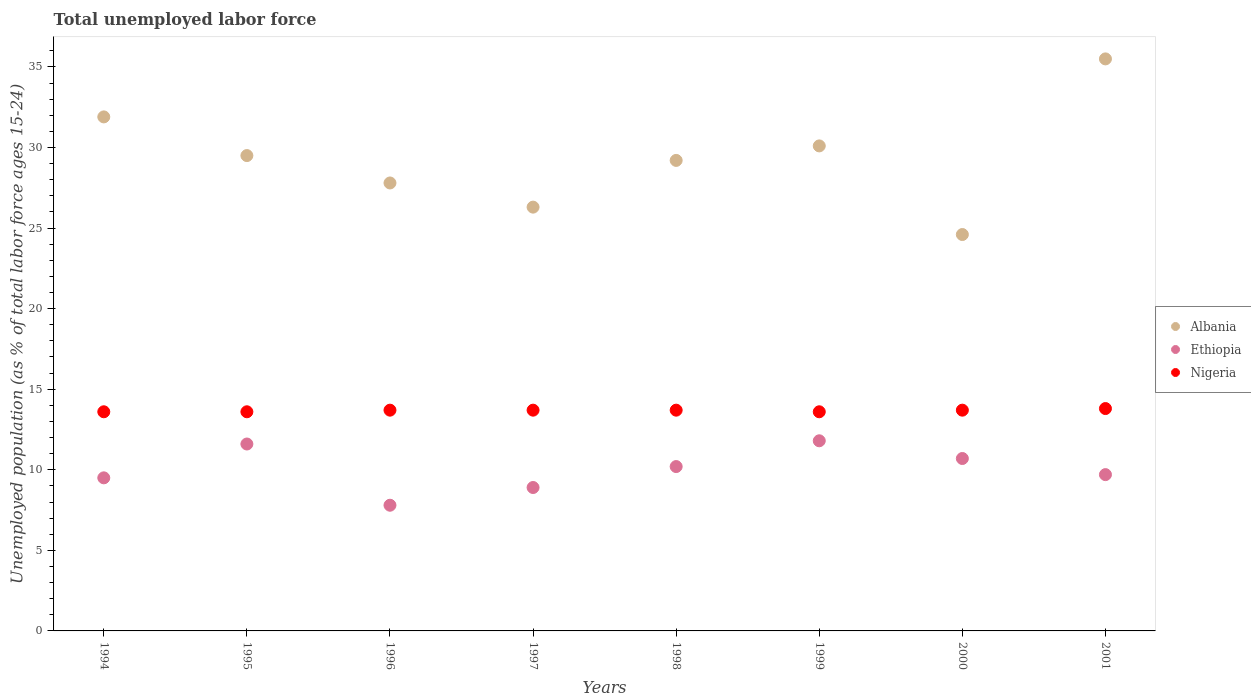Is the number of dotlines equal to the number of legend labels?
Provide a succinct answer. Yes. What is the percentage of unemployed population in in Albania in 1995?
Offer a very short reply. 29.5. Across all years, what is the maximum percentage of unemployed population in in Nigeria?
Provide a short and direct response. 13.8. Across all years, what is the minimum percentage of unemployed population in in Albania?
Your response must be concise. 24.6. In which year was the percentage of unemployed population in in Albania minimum?
Provide a succinct answer. 2000. What is the total percentage of unemployed population in in Ethiopia in the graph?
Your response must be concise. 80.2. What is the difference between the percentage of unemployed population in in Ethiopia in 1994 and that in 2000?
Make the answer very short. -1.2. What is the difference between the percentage of unemployed population in in Nigeria in 1997 and the percentage of unemployed population in in Albania in 1995?
Make the answer very short. -15.8. What is the average percentage of unemployed population in in Ethiopia per year?
Offer a very short reply. 10.02. In the year 1999, what is the difference between the percentage of unemployed population in in Nigeria and percentage of unemployed population in in Ethiopia?
Your response must be concise. 1.8. In how many years, is the percentage of unemployed population in in Nigeria greater than 16 %?
Give a very brief answer. 0. What is the ratio of the percentage of unemployed population in in Ethiopia in 1997 to that in 1999?
Offer a terse response. 0.75. What is the difference between the highest and the second highest percentage of unemployed population in in Nigeria?
Provide a short and direct response. 0.1. What is the difference between the highest and the lowest percentage of unemployed population in in Nigeria?
Offer a very short reply. 0.2. In how many years, is the percentage of unemployed population in in Nigeria greater than the average percentage of unemployed population in in Nigeria taken over all years?
Provide a short and direct response. 5. Is it the case that in every year, the sum of the percentage of unemployed population in in Ethiopia and percentage of unemployed population in in Albania  is greater than the percentage of unemployed population in in Nigeria?
Keep it short and to the point. Yes. Is the percentage of unemployed population in in Ethiopia strictly less than the percentage of unemployed population in in Nigeria over the years?
Give a very brief answer. Yes. What is the difference between two consecutive major ticks on the Y-axis?
Make the answer very short. 5. Does the graph contain grids?
Give a very brief answer. No. What is the title of the graph?
Keep it short and to the point. Total unemployed labor force. What is the label or title of the Y-axis?
Your response must be concise. Unemployed population (as % of total labor force ages 15-24). What is the Unemployed population (as % of total labor force ages 15-24) of Albania in 1994?
Offer a very short reply. 31.9. What is the Unemployed population (as % of total labor force ages 15-24) of Ethiopia in 1994?
Offer a terse response. 9.5. What is the Unemployed population (as % of total labor force ages 15-24) in Nigeria in 1994?
Provide a short and direct response. 13.6. What is the Unemployed population (as % of total labor force ages 15-24) of Albania in 1995?
Keep it short and to the point. 29.5. What is the Unemployed population (as % of total labor force ages 15-24) of Ethiopia in 1995?
Your answer should be very brief. 11.6. What is the Unemployed population (as % of total labor force ages 15-24) of Nigeria in 1995?
Give a very brief answer. 13.6. What is the Unemployed population (as % of total labor force ages 15-24) of Albania in 1996?
Offer a very short reply. 27.8. What is the Unemployed population (as % of total labor force ages 15-24) in Ethiopia in 1996?
Provide a short and direct response. 7.8. What is the Unemployed population (as % of total labor force ages 15-24) in Nigeria in 1996?
Your answer should be compact. 13.7. What is the Unemployed population (as % of total labor force ages 15-24) of Albania in 1997?
Ensure brevity in your answer.  26.3. What is the Unemployed population (as % of total labor force ages 15-24) of Ethiopia in 1997?
Make the answer very short. 8.9. What is the Unemployed population (as % of total labor force ages 15-24) in Nigeria in 1997?
Your answer should be compact. 13.7. What is the Unemployed population (as % of total labor force ages 15-24) in Albania in 1998?
Offer a very short reply. 29.2. What is the Unemployed population (as % of total labor force ages 15-24) of Ethiopia in 1998?
Offer a very short reply. 10.2. What is the Unemployed population (as % of total labor force ages 15-24) in Nigeria in 1998?
Provide a short and direct response. 13.7. What is the Unemployed population (as % of total labor force ages 15-24) of Albania in 1999?
Ensure brevity in your answer.  30.1. What is the Unemployed population (as % of total labor force ages 15-24) of Ethiopia in 1999?
Keep it short and to the point. 11.8. What is the Unemployed population (as % of total labor force ages 15-24) in Nigeria in 1999?
Provide a succinct answer. 13.6. What is the Unemployed population (as % of total labor force ages 15-24) of Albania in 2000?
Your answer should be compact. 24.6. What is the Unemployed population (as % of total labor force ages 15-24) of Ethiopia in 2000?
Make the answer very short. 10.7. What is the Unemployed population (as % of total labor force ages 15-24) in Nigeria in 2000?
Ensure brevity in your answer.  13.7. What is the Unemployed population (as % of total labor force ages 15-24) in Albania in 2001?
Keep it short and to the point. 35.5. What is the Unemployed population (as % of total labor force ages 15-24) in Ethiopia in 2001?
Your answer should be very brief. 9.7. What is the Unemployed population (as % of total labor force ages 15-24) in Nigeria in 2001?
Offer a very short reply. 13.8. Across all years, what is the maximum Unemployed population (as % of total labor force ages 15-24) in Albania?
Make the answer very short. 35.5. Across all years, what is the maximum Unemployed population (as % of total labor force ages 15-24) in Ethiopia?
Provide a succinct answer. 11.8. Across all years, what is the maximum Unemployed population (as % of total labor force ages 15-24) in Nigeria?
Ensure brevity in your answer.  13.8. Across all years, what is the minimum Unemployed population (as % of total labor force ages 15-24) in Albania?
Make the answer very short. 24.6. Across all years, what is the minimum Unemployed population (as % of total labor force ages 15-24) in Ethiopia?
Provide a succinct answer. 7.8. Across all years, what is the minimum Unemployed population (as % of total labor force ages 15-24) of Nigeria?
Your response must be concise. 13.6. What is the total Unemployed population (as % of total labor force ages 15-24) of Albania in the graph?
Your answer should be compact. 234.9. What is the total Unemployed population (as % of total labor force ages 15-24) of Ethiopia in the graph?
Your response must be concise. 80.2. What is the total Unemployed population (as % of total labor force ages 15-24) of Nigeria in the graph?
Provide a succinct answer. 109.4. What is the difference between the Unemployed population (as % of total labor force ages 15-24) of Albania in 1994 and that in 1995?
Your response must be concise. 2.4. What is the difference between the Unemployed population (as % of total labor force ages 15-24) in Ethiopia in 1994 and that in 1995?
Your response must be concise. -2.1. What is the difference between the Unemployed population (as % of total labor force ages 15-24) of Ethiopia in 1994 and that in 1996?
Offer a very short reply. 1.7. What is the difference between the Unemployed population (as % of total labor force ages 15-24) of Nigeria in 1994 and that in 1996?
Keep it short and to the point. -0.1. What is the difference between the Unemployed population (as % of total labor force ages 15-24) of Ethiopia in 1994 and that in 1997?
Offer a terse response. 0.6. What is the difference between the Unemployed population (as % of total labor force ages 15-24) in Albania in 1994 and that in 1998?
Provide a short and direct response. 2.7. What is the difference between the Unemployed population (as % of total labor force ages 15-24) of Ethiopia in 1994 and that in 1998?
Offer a terse response. -0.7. What is the difference between the Unemployed population (as % of total labor force ages 15-24) of Nigeria in 1994 and that in 1998?
Provide a short and direct response. -0.1. What is the difference between the Unemployed population (as % of total labor force ages 15-24) of Albania in 1994 and that in 1999?
Your answer should be compact. 1.8. What is the difference between the Unemployed population (as % of total labor force ages 15-24) in Ethiopia in 1994 and that in 1999?
Keep it short and to the point. -2.3. What is the difference between the Unemployed population (as % of total labor force ages 15-24) of Nigeria in 1994 and that in 2000?
Your response must be concise. -0.1. What is the difference between the Unemployed population (as % of total labor force ages 15-24) in Albania in 1994 and that in 2001?
Your answer should be very brief. -3.6. What is the difference between the Unemployed population (as % of total labor force ages 15-24) of Nigeria in 1994 and that in 2001?
Provide a short and direct response. -0.2. What is the difference between the Unemployed population (as % of total labor force ages 15-24) of Ethiopia in 1995 and that in 1996?
Your answer should be very brief. 3.8. What is the difference between the Unemployed population (as % of total labor force ages 15-24) of Nigeria in 1995 and that in 1996?
Offer a very short reply. -0.1. What is the difference between the Unemployed population (as % of total labor force ages 15-24) in Albania in 1995 and that in 1998?
Offer a very short reply. 0.3. What is the difference between the Unemployed population (as % of total labor force ages 15-24) of Nigeria in 1995 and that in 1998?
Make the answer very short. -0.1. What is the difference between the Unemployed population (as % of total labor force ages 15-24) of Nigeria in 1995 and that in 1999?
Make the answer very short. 0. What is the difference between the Unemployed population (as % of total labor force ages 15-24) of Albania in 1995 and that in 2000?
Provide a succinct answer. 4.9. What is the difference between the Unemployed population (as % of total labor force ages 15-24) of Ethiopia in 1995 and that in 2000?
Your answer should be very brief. 0.9. What is the difference between the Unemployed population (as % of total labor force ages 15-24) of Ethiopia in 1995 and that in 2001?
Make the answer very short. 1.9. What is the difference between the Unemployed population (as % of total labor force ages 15-24) of Nigeria in 1996 and that in 1997?
Your answer should be compact. 0. What is the difference between the Unemployed population (as % of total labor force ages 15-24) in Albania in 1996 and that in 1998?
Provide a short and direct response. -1.4. What is the difference between the Unemployed population (as % of total labor force ages 15-24) in Nigeria in 1996 and that in 1998?
Keep it short and to the point. 0. What is the difference between the Unemployed population (as % of total labor force ages 15-24) of Albania in 1996 and that in 2000?
Provide a succinct answer. 3.2. What is the difference between the Unemployed population (as % of total labor force ages 15-24) of Ethiopia in 1996 and that in 2000?
Make the answer very short. -2.9. What is the difference between the Unemployed population (as % of total labor force ages 15-24) in Nigeria in 1996 and that in 2000?
Make the answer very short. 0. What is the difference between the Unemployed population (as % of total labor force ages 15-24) of Ethiopia in 1996 and that in 2001?
Your response must be concise. -1.9. What is the difference between the Unemployed population (as % of total labor force ages 15-24) of Albania in 1997 and that in 1998?
Offer a very short reply. -2.9. What is the difference between the Unemployed population (as % of total labor force ages 15-24) of Nigeria in 1997 and that in 1998?
Keep it short and to the point. 0. What is the difference between the Unemployed population (as % of total labor force ages 15-24) of Nigeria in 1997 and that in 1999?
Give a very brief answer. 0.1. What is the difference between the Unemployed population (as % of total labor force ages 15-24) of Ethiopia in 1997 and that in 2000?
Make the answer very short. -1.8. What is the difference between the Unemployed population (as % of total labor force ages 15-24) in Albania in 1997 and that in 2001?
Your response must be concise. -9.2. What is the difference between the Unemployed population (as % of total labor force ages 15-24) of Ethiopia in 1997 and that in 2001?
Give a very brief answer. -0.8. What is the difference between the Unemployed population (as % of total labor force ages 15-24) of Nigeria in 1997 and that in 2001?
Provide a short and direct response. -0.1. What is the difference between the Unemployed population (as % of total labor force ages 15-24) of Albania in 1998 and that in 1999?
Provide a short and direct response. -0.9. What is the difference between the Unemployed population (as % of total labor force ages 15-24) of Nigeria in 1998 and that in 1999?
Your answer should be very brief. 0.1. What is the difference between the Unemployed population (as % of total labor force ages 15-24) of Ethiopia in 1998 and that in 2000?
Offer a very short reply. -0.5. What is the difference between the Unemployed population (as % of total labor force ages 15-24) in Albania in 1998 and that in 2001?
Provide a succinct answer. -6.3. What is the difference between the Unemployed population (as % of total labor force ages 15-24) of Nigeria in 1998 and that in 2001?
Ensure brevity in your answer.  -0.1. What is the difference between the Unemployed population (as % of total labor force ages 15-24) in Albania in 1999 and that in 2000?
Your response must be concise. 5.5. What is the difference between the Unemployed population (as % of total labor force ages 15-24) of Albania in 1999 and that in 2001?
Provide a short and direct response. -5.4. What is the difference between the Unemployed population (as % of total labor force ages 15-24) in Ethiopia in 1999 and that in 2001?
Offer a terse response. 2.1. What is the difference between the Unemployed population (as % of total labor force ages 15-24) in Ethiopia in 2000 and that in 2001?
Your answer should be compact. 1. What is the difference between the Unemployed population (as % of total labor force ages 15-24) of Nigeria in 2000 and that in 2001?
Your answer should be compact. -0.1. What is the difference between the Unemployed population (as % of total labor force ages 15-24) in Albania in 1994 and the Unemployed population (as % of total labor force ages 15-24) in Ethiopia in 1995?
Your answer should be compact. 20.3. What is the difference between the Unemployed population (as % of total labor force ages 15-24) in Ethiopia in 1994 and the Unemployed population (as % of total labor force ages 15-24) in Nigeria in 1995?
Your answer should be very brief. -4.1. What is the difference between the Unemployed population (as % of total labor force ages 15-24) of Albania in 1994 and the Unemployed population (as % of total labor force ages 15-24) of Ethiopia in 1996?
Your response must be concise. 24.1. What is the difference between the Unemployed population (as % of total labor force ages 15-24) of Albania in 1994 and the Unemployed population (as % of total labor force ages 15-24) of Nigeria in 1996?
Offer a terse response. 18.2. What is the difference between the Unemployed population (as % of total labor force ages 15-24) in Ethiopia in 1994 and the Unemployed population (as % of total labor force ages 15-24) in Nigeria in 1996?
Give a very brief answer. -4.2. What is the difference between the Unemployed population (as % of total labor force ages 15-24) of Albania in 1994 and the Unemployed population (as % of total labor force ages 15-24) of Nigeria in 1997?
Give a very brief answer. 18.2. What is the difference between the Unemployed population (as % of total labor force ages 15-24) in Albania in 1994 and the Unemployed population (as % of total labor force ages 15-24) in Ethiopia in 1998?
Your response must be concise. 21.7. What is the difference between the Unemployed population (as % of total labor force ages 15-24) of Ethiopia in 1994 and the Unemployed population (as % of total labor force ages 15-24) of Nigeria in 1998?
Your answer should be very brief. -4.2. What is the difference between the Unemployed population (as % of total labor force ages 15-24) in Albania in 1994 and the Unemployed population (as % of total labor force ages 15-24) in Ethiopia in 1999?
Give a very brief answer. 20.1. What is the difference between the Unemployed population (as % of total labor force ages 15-24) of Ethiopia in 1994 and the Unemployed population (as % of total labor force ages 15-24) of Nigeria in 1999?
Offer a very short reply. -4.1. What is the difference between the Unemployed population (as % of total labor force ages 15-24) of Albania in 1994 and the Unemployed population (as % of total labor force ages 15-24) of Ethiopia in 2000?
Your answer should be very brief. 21.2. What is the difference between the Unemployed population (as % of total labor force ages 15-24) in Albania in 1995 and the Unemployed population (as % of total labor force ages 15-24) in Ethiopia in 1996?
Your answer should be very brief. 21.7. What is the difference between the Unemployed population (as % of total labor force ages 15-24) in Albania in 1995 and the Unemployed population (as % of total labor force ages 15-24) in Ethiopia in 1997?
Your response must be concise. 20.6. What is the difference between the Unemployed population (as % of total labor force ages 15-24) of Albania in 1995 and the Unemployed population (as % of total labor force ages 15-24) of Nigeria in 1997?
Your answer should be very brief. 15.8. What is the difference between the Unemployed population (as % of total labor force ages 15-24) in Albania in 1995 and the Unemployed population (as % of total labor force ages 15-24) in Ethiopia in 1998?
Provide a succinct answer. 19.3. What is the difference between the Unemployed population (as % of total labor force ages 15-24) of Albania in 1995 and the Unemployed population (as % of total labor force ages 15-24) of Nigeria in 1998?
Give a very brief answer. 15.8. What is the difference between the Unemployed population (as % of total labor force ages 15-24) in Ethiopia in 1995 and the Unemployed population (as % of total labor force ages 15-24) in Nigeria in 1998?
Your answer should be very brief. -2.1. What is the difference between the Unemployed population (as % of total labor force ages 15-24) of Albania in 1995 and the Unemployed population (as % of total labor force ages 15-24) of Ethiopia in 1999?
Your answer should be compact. 17.7. What is the difference between the Unemployed population (as % of total labor force ages 15-24) in Albania in 1995 and the Unemployed population (as % of total labor force ages 15-24) in Nigeria in 1999?
Offer a terse response. 15.9. What is the difference between the Unemployed population (as % of total labor force ages 15-24) in Ethiopia in 1995 and the Unemployed population (as % of total labor force ages 15-24) in Nigeria in 1999?
Give a very brief answer. -2. What is the difference between the Unemployed population (as % of total labor force ages 15-24) of Albania in 1995 and the Unemployed population (as % of total labor force ages 15-24) of Ethiopia in 2000?
Offer a terse response. 18.8. What is the difference between the Unemployed population (as % of total labor force ages 15-24) in Albania in 1995 and the Unemployed population (as % of total labor force ages 15-24) in Nigeria in 2000?
Offer a terse response. 15.8. What is the difference between the Unemployed population (as % of total labor force ages 15-24) of Albania in 1995 and the Unemployed population (as % of total labor force ages 15-24) of Ethiopia in 2001?
Your answer should be compact. 19.8. What is the difference between the Unemployed population (as % of total labor force ages 15-24) of Ethiopia in 1996 and the Unemployed population (as % of total labor force ages 15-24) of Nigeria in 1997?
Offer a terse response. -5.9. What is the difference between the Unemployed population (as % of total labor force ages 15-24) in Albania in 1996 and the Unemployed population (as % of total labor force ages 15-24) in Ethiopia in 1998?
Your response must be concise. 17.6. What is the difference between the Unemployed population (as % of total labor force ages 15-24) in Albania in 1996 and the Unemployed population (as % of total labor force ages 15-24) in Ethiopia in 1999?
Provide a short and direct response. 16. What is the difference between the Unemployed population (as % of total labor force ages 15-24) of Ethiopia in 1996 and the Unemployed population (as % of total labor force ages 15-24) of Nigeria in 1999?
Make the answer very short. -5.8. What is the difference between the Unemployed population (as % of total labor force ages 15-24) of Albania in 1996 and the Unemployed population (as % of total labor force ages 15-24) of Ethiopia in 2000?
Your answer should be very brief. 17.1. What is the difference between the Unemployed population (as % of total labor force ages 15-24) of Albania in 1996 and the Unemployed population (as % of total labor force ages 15-24) of Nigeria in 2000?
Your answer should be compact. 14.1. What is the difference between the Unemployed population (as % of total labor force ages 15-24) in Ethiopia in 1996 and the Unemployed population (as % of total labor force ages 15-24) in Nigeria in 2000?
Your answer should be very brief. -5.9. What is the difference between the Unemployed population (as % of total labor force ages 15-24) in Albania in 1996 and the Unemployed population (as % of total labor force ages 15-24) in Ethiopia in 2001?
Keep it short and to the point. 18.1. What is the difference between the Unemployed population (as % of total labor force ages 15-24) in Albania in 1996 and the Unemployed population (as % of total labor force ages 15-24) in Nigeria in 2001?
Make the answer very short. 14. What is the difference between the Unemployed population (as % of total labor force ages 15-24) of Ethiopia in 1996 and the Unemployed population (as % of total labor force ages 15-24) of Nigeria in 2001?
Give a very brief answer. -6. What is the difference between the Unemployed population (as % of total labor force ages 15-24) in Albania in 1997 and the Unemployed population (as % of total labor force ages 15-24) in Ethiopia in 1998?
Ensure brevity in your answer.  16.1. What is the difference between the Unemployed population (as % of total labor force ages 15-24) in Ethiopia in 1997 and the Unemployed population (as % of total labor force ages 15-24) in Nigeria in 1998?
Give a very brief answer. -4.8. What is the difference between the Unemployed population (as % of total labor force ages 15-24) of Albania in 1997 and the Unemployed population (as % of total labor force ages 15-24) of Ethiopia in 2000?
Keep it short and to the point. 15.6. What is the difference between the Unemployed population (as % of total labor force ages 15-24) in Albania in 1997 and the Unemployed population (as % of total labor force ages 15-24) in Ethiopia in 2001?
Your response must be concise. 16.6. What is the difference between the Unemployed population (as % of total labor force ages 15-24) of Albania in 1997 and the Unemployed population (as % of total labor force ages 15-24) of Nigeria in 2001?
Your response must be concise. 12.5. What is the difference between the Unemployed population (as % of total labor force ages 15-24) in Ethiopia in 1997 and the Unemployed population (as % of total labor force ages 15-24) in Nigeria in 2001?
Your answer should be compact. -4.9. What is the difference between the Unemployed population (as % of total labor force ages 15-24) of Albania in 1998 and the Unemployed population (as % of total labor force ages 15-24) of Ethiopia in 1999?
Provide a succinct answer. 17.4. What is the difference between the Unemployed population (as % of total labor force ages 15-24) of Ethiopia in 1998 and the Unemployed population (as % of total labor force ages 15-24) of Nigeria in 2000?
Your answer should be very brief. -3.5. What is the difference between the Unemployed population (as % of total labor force ages 15-24) of Albania in 1998 and the Unemployed population (as % of total labor force ages 15-24) of Ethiopia in 2001?
Keep it short and to the point. 19.5. What is the difference between the Unemployed population (as % of total labor force ages 15-24) in Albania in 1998 and the Unemployed population (as % of total labor force ages 15-24) in Nigeria in 2001?
Make the answer very short. 15.4. What is the difference between the Unemployed population (as % of total labor force ages 15-24) of Albania in 1999 and the Unemployed population (as % of total labor force ages 15-24) of Ethiopia in 2000?
Provide a succinct answer. 19.4. What is the difference between the Unemployed population (as % of total labor force ages 15-24) of Albania in 1999 and the Unemployed population (as % of total labor force ages 15-24) of Nigeria in 2000?
Offer a terse response. 16.4. What is the difference between the Unemployed population (as % of total labor force ages 15-24) of Albania in 1999 and the Unemployed population (as % of total labor force ages 15-24) of Ethiopia in 2001?
Offer a terse response. 20.4. What is the difference between the Unemployed population (as % of total labor force ages 15-24) of Albania in 1999 and the Unemployed population (as % of total labor force ages 15-24) of Nigeria in 2001?
Provide a succinct answer. 16.3. What is the average Unemployed population (as % of total labor force ages 15-24) in Albania per year?
Give a very brief answer. 29.36. What is the average Unemployed population (as % of total labor force ages 15-24) in Ethiopia per year?
Offer a very short reply. 10.03. What is the average Unemployed population (as % of total labor force ages 15-24) of Nigeria per year?
Provide a short and direct response. 13.68. In the year 1994, what is the difference between the Unemployed population (as % of total labor force ages 15-24) in Albania and Unemployed population (as % of total labor force ages 15-24) in Ethiopia?
Make the answer very short. 22.4. In the year 1994, what is the difference between the Unemployed population (as % of total labor force ages 15-24) in Albania and Unemployed population (as % of total labor force ages 15-24) in Nigeria?
Give a very brief answer. 18.3. In the year 1995, what is the difference between the Unemployed population (as % of total labor force ages 15-24) of Ethiopia and Unemployed population (as % of total labor force ages 15-24) of Nigeria?
Provide a succinct answer. -2. In the year 1996, what is the difference between the Unemployed population (as % of total labor force ages 15-24) in Albania and Unemployed population (as % of total labor force ages 15-24) in Nigeria?
Your answer should be compact. 14.1. In the year 1996, what is the difference between the Unemployed population (as % of total labor force ages 15-24) in Ethiopia and Unemployed population (as % of total labor force ages 15-24) in Nigeria?
Your answer should be very brief. -5.9. In the year 1997, what is the difference between the Unemployed population (as % of total labor force ages 15-24) of Albania and Unemployed population (as % of total labor force ages 15-24) of Ethiopia?
Offer a terse response. 17.4. In the year 1998, what is the difference between the Unemployed population (as % of total labor force ages 15-24) of Albania and Unemployed population (as % of total labor force ages 15-24) of Ethiopia?
Make the answer very short. 19. In the year 1999, what is the difference between the Unemployed population (as % of total labor force ages 15-24) in Albania and Unemployed population (as % of total labor force ages 15-24) in Ethiopia?
Provide a short and direct response. 18.3. In the year 1999, what is the difference between the Unemployed population (as % of total labor force ages 15-24) in Albania and Unemployed population (as % of total labor force ages 15-24) in Nigeria?
Keep it short and to the point. 16.5. In the year 1999, what is the difference between the Unemployed population (as % of total labor force ages 15-24) of Ethiopia and Unemployed population (as % of total labor force ages 15-24) of Nigeria?
Provide a succinct answer. -1.8. In the year 2000, what is the difference between the Unemployed population (as % of total labor force ages 15-24) of Albania and Unemployed population (as % of total labor force ages 15-24) of Nigeria?
Ensure brevity in your answer.  10.9. In the year 2001, what is the difference between the Unemployed population (as % of total labor force ages 15-24) in Albania and Unemployed population (as % of total labor force ages 15-24) in Ethiopia?
Make the answer very short. 25.8. In the year 2001, what is the difference between the Unemployed population (as % of total labor force ages 15-24) of Albania and Unemployed population (as % of total labor force ages 15-24) of Nigeria?
Offer a terse response. 21.7. What is the ratio of the Unemployed population (as % of total labor force ages 15-24) in Albania in 1994 to that in 1995?
Your answer should be compact. 1.08. What is the ratio of the Unemployed population (as % of total labor force ages 15-24) in Ethiopia in 1994 to that in 1995?
Provide a succinct answer. 0.82. What is the ratio of the Unemployed population (as % of total labor force ages 15-24) in Nigeria in 1994 to that in 1995?
Ensure brevity in your answer.  1. What is the ratio of the Unemployed population (as % of total labor force ages 15-24) of Albania in 1994 to that in 1996?
Your response must be concise. 1.15. What is the ratio of the Unemployed population (as % of total labor force ages 15-24) of Ethiopia in 1994 to that in 1996?
Provide a succinct answer. 1.22. What is the ratio of the Unemployed population (as % of total labor force ages 15-24) of Albania in 1994 to that in 1997?
Keep it short and to the point. 1.21. What is the ratio of the Unemployed population (as % of total labor force ages 15-24) in Ethiopia in 1994 to that in 1997?
Make the answer very short. 1.07. What is the ratio of the Unemployed population (as % of total labor force ages 15-24) in Nigeria in 1994 to that in 1997?
Make the answer very short. 0.99. What is the ratio of the Unemployed population (as % of total labor force ages 15-24) of Albania in 1994 to that in 1998?
Give a very brief answer. 1.09. What is the ratio of the Unemployed population (as % of total labor force ages 15-24) in Ethiopia in 1994 to that in 1998?
Keep it short and to the point. 0.93. What is the ratio of the Unemployed population (as % of total labor force ages 15-24) of Nigeria in 1994 to that in 1998?
Your answer should be compact. 0.99. What is the ratio of the Unemployed population (as % of total labor force ages 15-24) of Albania in 1994 to that in 1999?
Ensure brevity in your answer.  1.06. What is the ratio of the Unemployed population (as % of total labor force ages 15-24) in Ethiopia in 1994 to that in 1999?
Give a very brief answer. 0.81. What is the ratio of the Unemployed population (as % of total labor force ages 15-24) in Albania in 1994 to that in 2000?
Keep it short and to the point. 1.3. What is the ratio of the Unemployed population (as % of total labor force ages 15-24) in Ethiopia in 1994 to that in 2000?
Keep it short and to the point. 0.89. What is the ratio of the Unemployed population (as % of total labor force ages 15-24) in Albania in 1994 to that in 2001?
Offer a very short reply. 0.9. What is the ratio of the Unemployed population (as % of total labor force ages 15-24) in Ethiopia in 1994 to that in 2001?
Your response must be concise. 0.98. What is the ratio of the Unemployed population (as % of total labor force ages 15-24) of Nigeria in 1994 to that in 2001?
Provide a succinct answer. 0.99. What is the ratio of the Unemployed population (as % of total labor force ages 15-24) of Albania in 1995 to that in 1996?
Your answer should be very brief. 1.06. What is the ratio of the Unemployed population (as % of total labor force ages 15-24) of Ethiopia in 1995 to that in 1996?
Offer a very short reply. 1.49. What is the ratio of the Unemployed population (as % of total labor force ages 15-24) of Nigeria in 1995 to that in 1996?
Your answer should be compact. 0.99. What is the ratio of the Unemployed population (as % of total labor force ages 15-24) of Albania in 1995 to that in 1997?
Make the answer very short. 1.12. What is the ratio of the Unemployed population (as % of total labor force ages 15-24) of Ethiopia in 1995 to that in 1997?
Ensure brevity in your answer.  1.3. What is the ratio of the Unemployed population (as % of total labor force ages 15-24) in Albania in 1995 to that in 1998?
Make the answer very short. 1.01. What is the ratio of the Unemployed population (as % of total labor force ages 15-24) of Ethiopia in 1995 to that in 1998?
Your answer should be compact. 1.14. What is the ratio of the Unemployed population (as % of total labor force ages 15-24) of Nigeria in 1995 to that in 1998?
Ensure brevity in your answer.  0.99. What is the ratio of the Unemployed population (as % of total labor force ages 15-24) in Albania in 1995 to that in 1999?
Provide a succinct answer. 0.98. What is the ratio of the Unemployed population (as % of total labor force ages 15-24) in Ethiopia in 1995 to that in 1999?
Your answer should be very brief. 0.98. What is the ratio of the Unemployed population (as % of total labor force ages 15-24) in Albania in 1995 to that in 2000?
Make the answer very short. 1.2. What is the ratio of the Unemployed population (as % of total labor force ages 15-24) in Ethiopia in 1995 to that in 2000?
Your response must be concise. 1.08. What is the ratio of the Unemployed population (as % of total labor force ages 15-24) in Nigeria in 1995 to that in 2000?
Provide a short and direct response. 0.99. What is the ratio of the Unemployed population (as % of total labor force ages 15-24) in Albania in 1995 to that in 2001?
Keep it short and to the point. 0.83. What is the ratio of the Unemployed population (as % of total labor force ages 15-24) in Ethiopia in 1995 to that in 2001?
Provide a short and direct response. 1.2. What is the ratio of the Unemployed population (as % of total labor force ages 15-24) in Nigeria in 1995 to that in 2001?
Provide a succinct answer. 0.99. What is the ratio of the Unemployed population (as % of total labor force ages 15-24) in Albania in 1996 to that in 1997?
Keep it short and to the point. 1.06. What is the ratio of the Unemployed population (as % of total labor force ages 15-24) of Ethiopia in 1996 to that in 1997?
Offer a terse response. 0.88. What is the ratio of the Unemployed population (as % of total labor force ages 15-24) in Albania in 1996 to that in 1998?
Your answer should be compact. 0.95. What is the ratio of the Unemployed population (as % of total labor force ages 15-24) of Ethiopia in 1996 to that in 1998?
Ensure brevity in your answer.  0.76. What is the ratio of the Unemployed population (as % of total labor force ages 15-24) in Albania in 1996 to that in 1999?
Ensure brevity in your answer.  0.92. What is the ratio of the Unemployed population (as % of total labor force ages 15-24) in Ethiopia in 1996 to that in 1999?
Provide a succinct answer. 0.66. What is the ratio of the Unemployed population (as % of total labor force ages 15-24) in Nigeria in 1996 to that in 1999?
Offer a terse response. 1.01. What is the ratio of the Unemployed population (as % of total labor force ages 15-24) in Albania in 1996 to that in 2000?
Offer a terse response. 1.13. What is the ratio of the Unemployed population (as % of total labor force ages 15-24) in Ethiopia in 1996 to that in 2000?
Offer a terse response. 0.73. What is the ratio of the Unemployed population (as % of total labor force ages 15-24) in Nigeria in 1996 to that in 2000?
Ensure brevity in your answer.  1. What is the ratio of the Unemployed population (as % of total labor force ages 15-24) of Albania in 1996 to that in 2001?
Offer a very short reply. 0.78. What is the ratio of the Unemployed population (as % of total labor force ages 15-24) of Ethiopia in 1996 to that in 2001?
Your answer should be very brief. 0.8. What is the ratio of the Unemployed population (as % of total labor force ages 15-24) in Nigeria in 1996 to that in 2001?
Provide a short and direct response. 0.99. What is the ratio of the Unemployed population (as % of total labor force ages 15-24) of Albania in 1997 to that in 1998?
Your answer should be very brief. 0.9. What is the ratio of the Unemployed population (as % of total labor force ages 15-24) in Ethiopia in 1997 to that in 1998?
Provide a short and direct response. 0.87. What is the ratio of the Unemployed population (as % of total labor force ages 15-24) of Albania in 1997 to that in 1999?
Give a very brief answer. 0.87. What is the ratio of the Unemployed population (as % of total labor force ages 15-24) in Ethiopia in 1997 to that in 1999?
Your answer should be compact. 0.75. What is the ratio of the Unemployed population (as % of total labor force ages 15-24) in Nigeria in 1997 to that in 1999?
Make the answer very short. 1.01. What is the ratio of the Unemployed population (as % of total labor force ages 15-24) in Albania in 1997 to that in 2000?
Provide a succinct answer. 1.07. What is the ratio of the Unemployed population (as % of total labor force ages 15-24) in Ethiopia in 1997 to that in 2000?
Offer a very short reply. 0.83. What is the ratio of the Unemployed population (as % of total labor force ages 15-24) in Albania in 1997 to that in 2001?
Make the answer very short. 0.74. What is the ratio of the Unemployed population (as % of total labor force ages 15-24) in Ethiopia in 1997 to that in 2001?
Provide a short and direct response. 0.92. What is the ratio of the Unemployed population (as % of total labor force ages 15-24) in Nigeria in 1997 to that in 2001?
Your answer should be very brief. 0.99. What is the ratio of the Unemployed population (as % of total labor force ages 15-24) of Albania in 1998 to that in 1999?
Give a very brief answer. 0.97. What is the ratio of the Unemployed population (as % of total labor force ages 15-24) of Ethiopia in 1998 to that in 1999?
Offer a very short reply. 0.86. What is the ratio of the Unemployed population (as % of total labor force ages 15-24) of Nigeria in 1998 to that in 1999?
Provide a short and direct response. 1.01. What is the ratio of the Unemployed population (as % of total labor force ages 15-24) in Albania in 1998 to that in 2000?
Make the answer very short. 1.19. What is the ratio of the Unemployed population (as % of total labor force ages 15-24) in Ethiopia in 1998 to that in 2000?
Keep it short and to the point. 0.95. What is the ratio of the Unemployed population (as % of total labor force ages 15-24) of Nigeria in 1998 to that in 2000?
Ensure brevity in your answer.  1. What is the ratio of the Unemployed population (as % of total labor force ages 15-24) in Albania in 1998 to that in 2001?
Offer a very short reply. 0.82. What is the ratio of the Unemployed population (as % of total labor force ages 15-24) of Ethiopia in 1998 to that in 2001?
Keep it short and to the point. 1.05. What is the ratio of the Unemployed population (as % of total labor force ages 15-24) of Nigeria in 1998 to that in 2001?
Offer a very short reply. 0.99. What is the ratio of the Unemployed population (as % of total labor force ages 15-24) in Albania in 1999 to that in 2000?
Your answer should be compact. 1.22. What is the ratio of the Unemployed population (as % of total labor force ages 15-24) in Ethiopia in 1999 to that in 2000?
Your answer should be very brief. 1.1. What is the ratio of the Unemployed population (as % of total labor force ages 15-24) in Albania in 1999 to that in 2001?
Offer a very short reply. 0.85. What is the ratio of the Unemployed population (as % of total labor force ages 15-24) of Ethiopia in 1999 to that in 2001?
Your answer should be compact. 1.22. What is the ratio of the Unemployed population (as % of total labor force ages 15-24) in Nigeria in 1999 to that in 2001?
Keep it short and to the point. 0.99. What is the ratio of the Unemployed population (as % of total labor force ages 15-24) of Albania in 2000 to that in 2001?
Provide a short and direct response. 0.69. What is the ratio of the Unemployed population (as % of total labor force ages 15-24) in Ethiopia in 2000 to that in 2001?
Offer a terse response. 1.1. What is the ratio of the Unemployed population (as % of total labor force ages 15-24) in Nigeria in 2000 to that in 2001?
Your response must be concise. 0.99. What is the difference between the highest and the second highest Unemployed population (as % of total labor force ages 15-24) in Nigeria?
Keep it short and to the point. 0.1. What is the difference between the highest and the lowest Unemployed population (as % of total labor force ages 15-24) in Albania?
Offer a very short reply. 10.9. What is the difference between the highest and the lowest Unemployed population (as % of total labor force ages 15-24) of Nigeria?
Give a very brief answer. 0.2. 